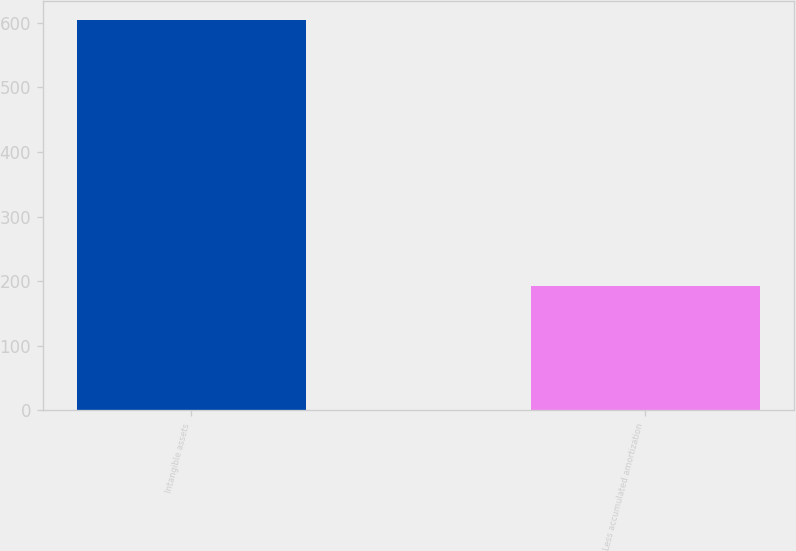Convert chart. <chart><loc_0><loc_0><loc_500><loc_500><bar_chart><fcel>Intangible assets<fcel>Less accumulated amortization<nl><fcel>604<fcel>193<nl></chart> 